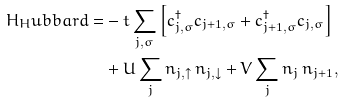<formula> <loc_0><loc_0><loc_500><loc_500>H _ { H } u b b a r d = & - t \sum _ { j , \sigma } \left [ c ^ { \dagger } _ { j , \sigma } c _ { j + 1 , \sigma } + c ^ { \dagger } _ { j + 1 , \sigma } c _ { j , \sigma } \right ] \\ & + U \sum _ { j } n _ { j , \uparrow } \, n _ { j , \downarrow } + V \sum _ { j } n _ { j } \, n _ { j + 1 } ,</formula> 